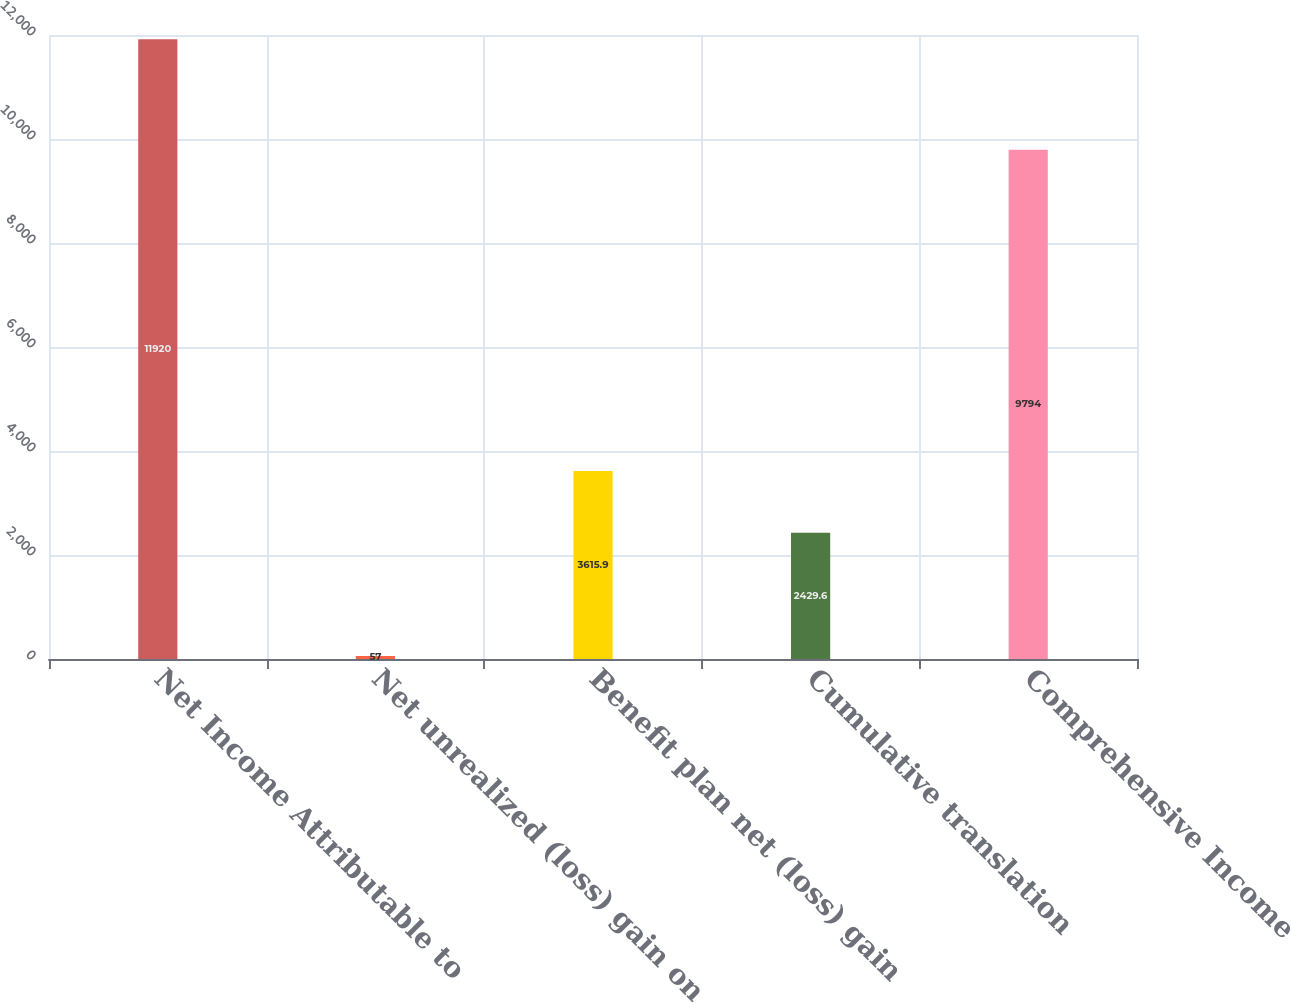Convert chart to OTSL. <chart><loc_0><loc_0><loc_500><loc_500><bar_chart><fcel>Net Income Attributable to<fcel>Net unrealized (loss) gain on<fcel>Benefit plan net (loss) gain<fcel>Cumulative translation<fcel>Comprehensive Income<nl><fcel>11920<fcel>57<fcel>3615.9<fcel>2429.6<fcel>9794<nl></chart> 